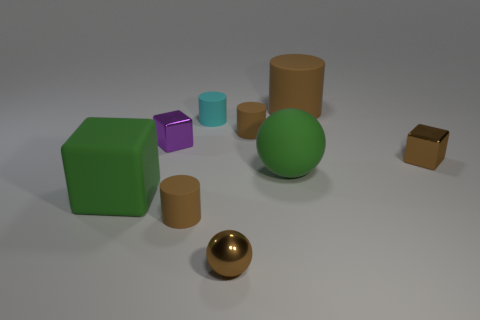What number of big green objects have the same material as the cyan thing?
Provide a succinct answer. 2. Do the brown cylinder in front of the large green matte cube and the block right of the small purple object have the same size?
Your answer should be very brief. Yes. What is the color of the tiny cylinder that is in front of the big rubber sphere that is right of the small brown cylinder that is behind the small purple block?
Make the answer very short. Brown. Is there another large rubber thing of the same shape as the purple object?
Provide a succinct answer. Yes. Are there the same number of matte objects that are in front of the tiny ball and large objects behind the purple object?
Your response must be concise. No. There is a large matte thing that is right of the rubber sphere; is its shape the same as the cyan object?
Give a very brief answer. Yes. Does the small cyan matte thing have the same shape as the purple metal object?
Make the answer very short. No. What number of matte things are brown objects or large yellow balls?
Offer a very short reply. 3. There is a small ball that is the same color as the big rubber cylinder; what is its material?
Your response must be concise. Metal. Does the rubber cube have the same size as the green sphere?
Provide a succinct answer. Yes. 